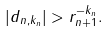Convert formula to latex. <formula><loc_0><loc_0><loc_500><loc_500>| d _ { n , k _ { n } } | > r _ { n + 1 } ^ { - k _ { n } } .</formula> 